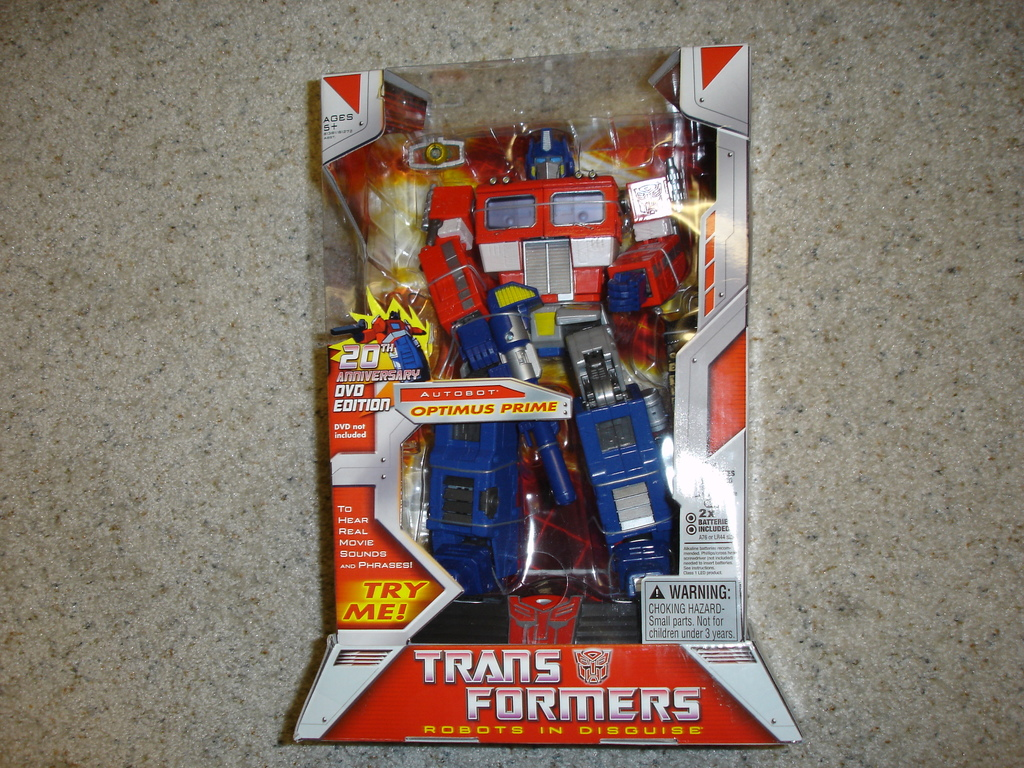What makes this Transformer toy special compared to others? This Optimus Prime toy is special as it celebrates the 20th Anniversary of the Transformers series with a DVD Edition packaging, highlighting its collectible value and historical significance. It also includes interactive features which allow it to speak and make sounds when prompted. 